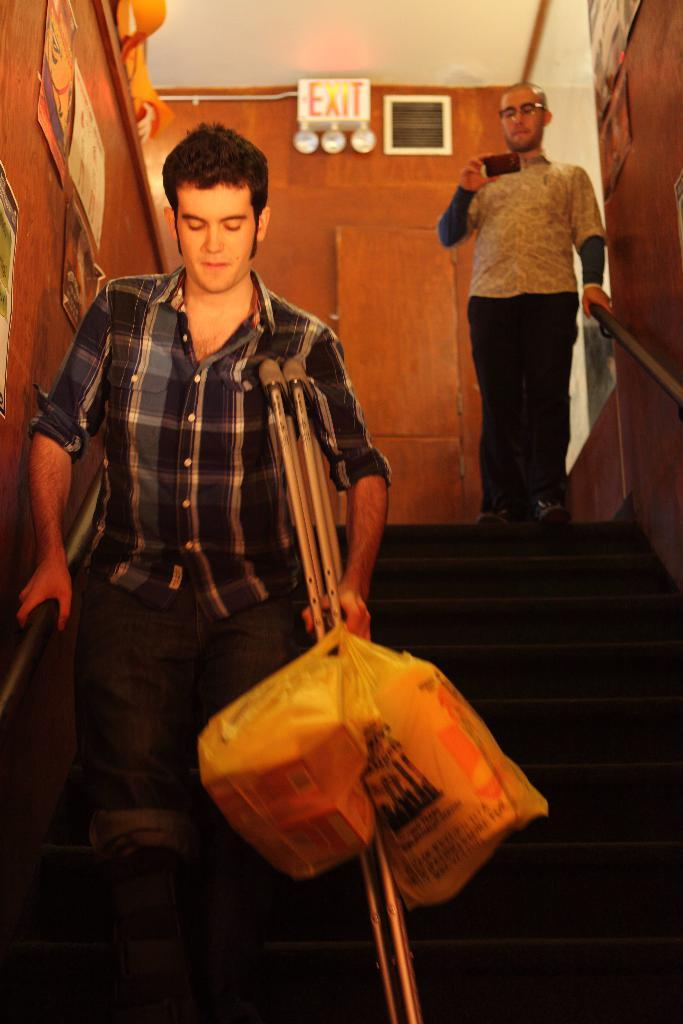How many people are in the image? There are two persons standing in the center of the image. What are the persons holding in the image? The persons are holding objects. What can be seen in the background of the image? There is a wall, a sign board, and a collection of photos in the background of the image. What type of harmony is being played by the persons in the image? There is no indication of any musical instruments or performance in the image, so it cannot be determined if any harmony is being played. 